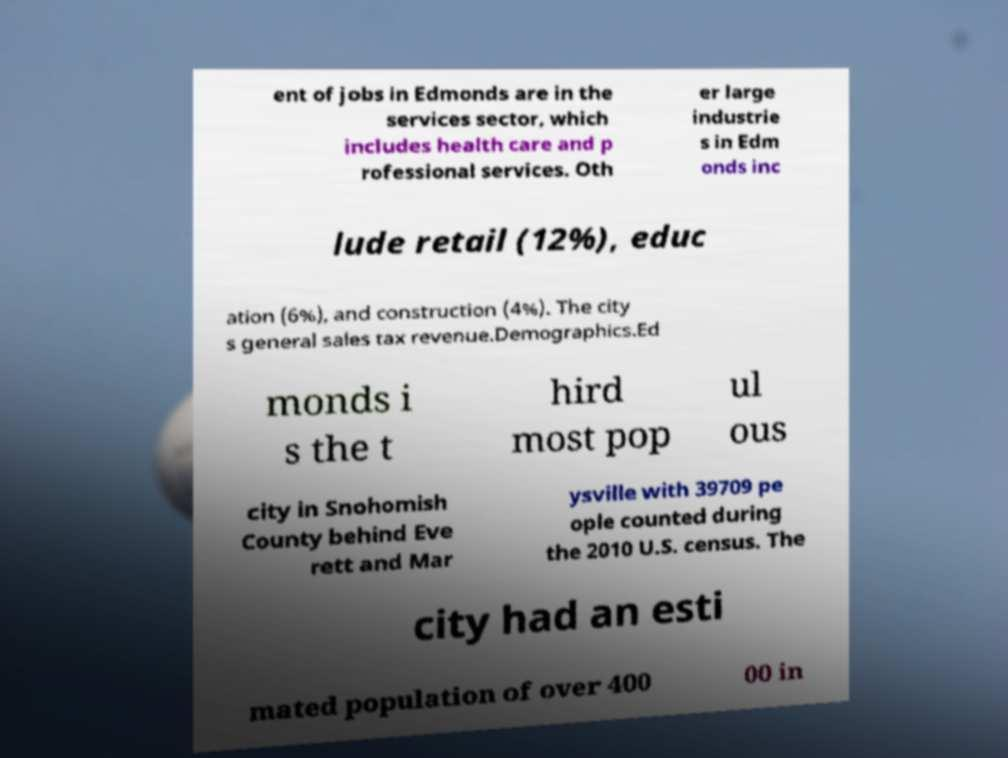There's text embedded in this image that I need extracted. Can you transcribe it verbatim? ent of jobs in Edmonds are in the services sector, which includes health care and p rofessional services. Oth er large industrie s in Edm onds inc lude retail (12%), educ ation (6%), and construction (4%). The city s general sales tax revenue.Demographics.Ed monds i s the t hird most pop ul ous city in Snohomish County behind Eve rett and Mar ysville with 39709 pe ople counted during the 2010 U.S. census. The city had an esti mated population of over 400 00 in 